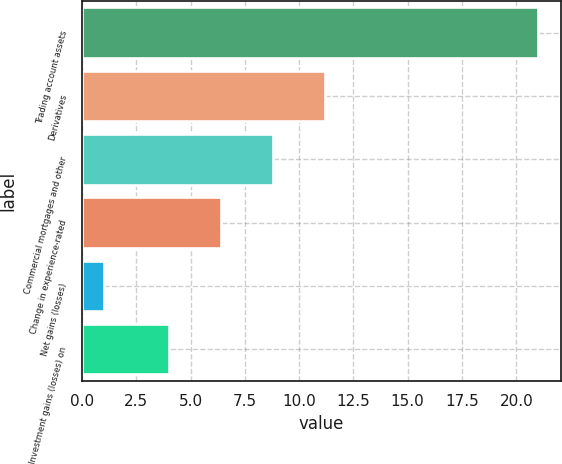Convert chart. <chart><loc_0><loc_0><loc_500><loc_500><bar_chart><fcel>Trading account assets<fcel>Derivatives<fcel>Commercial mortgages and other<fcel>Change in experience-rated<fcel>Net gains (losses)<fcel>Investment gains (losses) on<nl><fcel>21<fcel>11.2<fcel>8.8<fcel>6.4<fcel>1<fcel>4<nl></chart> 